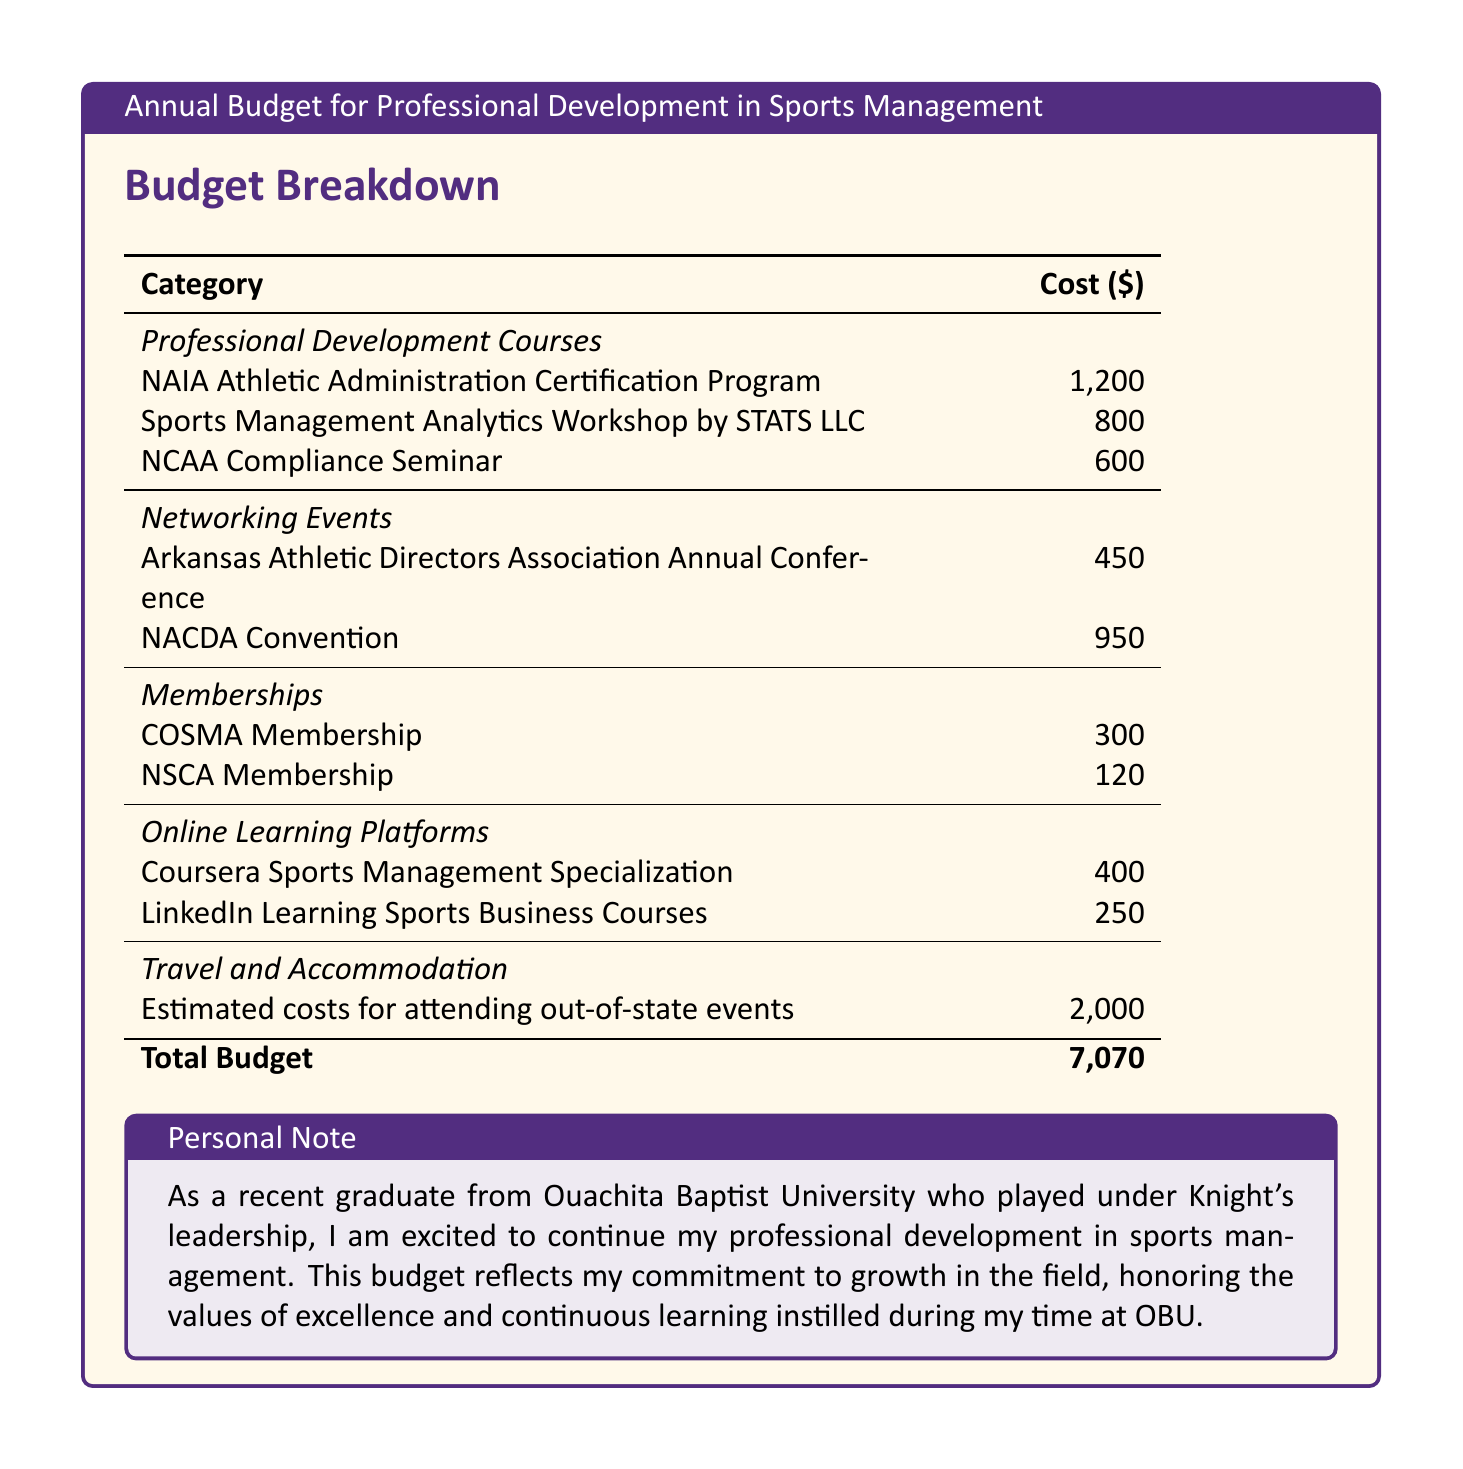What is the total budget? The total budget is listed at the bottom of the document, summing all expenses detailed in the budget breakdown.
Answer: 7,070 What is the cost of the NCAA Compliance Seminar? The document specifies the cost of the NCAA Compliance Seminar under the Professional Development Courses section.
Answer: 600 What is included under Networking Events? The section outlines two specific events, providing their respective costs, which reflects the total spent on networking.
Answer: Arkansas Athletic Directors Association Annual Conference, NACDA Convention How much is allocated for travel and accommodation? The travel and accommodation category lists the estimated costs associated with attending out-of-state events.
Answer: 2,000 What is the name of the online learning platform that offers Sports Business Courses? The budget includes a category for online learning platforms, listing a specific platform that provides sports business courses.
Answer: LinkedIn Learning Which professional development course costs the most? By comparing the costs listed for all professional development courses, we find the one with the highest price.
Answer: NAIA Athletic Administration Certification Program What is the total cost of memberships listed in the budget? The membership section includes two types of memberships, and the total cost is obtained by adding both amounts.
Answer: 420 Which networking event costs the least? We examine the networking events and find the one with the lowest expense associated with it.
Answer: Arkansas Athletic Directors Association Annual Conference What color scheme is used for the document? The document features a specific color scheme, reflecting school colors which are highlighted throughout.
Answer: Ouachita purple and gold 